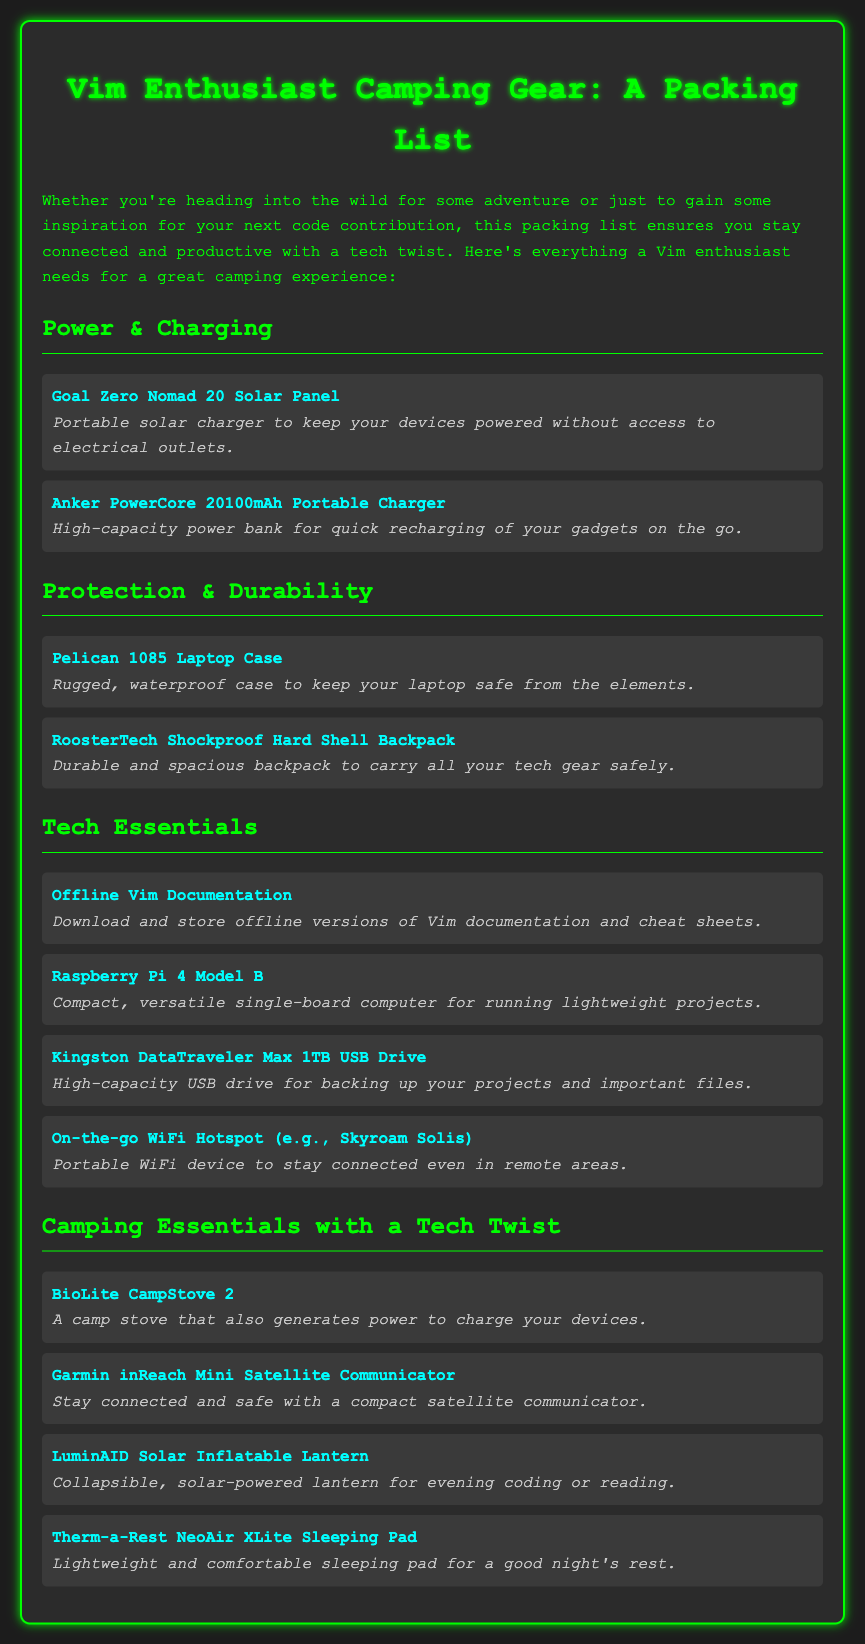what is the name of the portable solar charger? The document lists the "Goal Zero Nomad 20 Solar Panel" as a portable solar charger.
Answer: Goal Zero Nomad 20 Solar Panel how many items are listed under Tech Essentials? The document details four items in the Tech Essentials category.
Answer: 4 what type of device is the Garmin inReach Mini? The Garmin inReach Mini is categorized as a "Satellite Communicator."
Answer: Satellite Communicator what is the purpose of the BioLite CampStove 2? The BioLite CampStove 2 serves as both a camp stove and a power generator for charging devices.
Answer: Generates power what is the storage capacity of Kingston DataTraveler Max USB Drive? The Kingston DataTraveler Max USB Drive has a capacity of 1TB.
Answer: 1TB what kind of protection does the Pelican 1085 case offer? The Pelican 1085 Laptop Case is described as rugged and waterproof, ensuring protection from the elements.
Answer: Rugged, waterproof which item provides a solar-powered light source? The LuminAID Solar Inflatable Lantern is the item that provides solar-powered light.
Answer: LuminAID Solar Inflatable Lantern what is recommended for offline Vim documentation? The document advises to download and store offline versions of Vim documentation and cheat sheets.
Answer: Offline versions of Vim documentation how does the BioLite CampStove 2 charge devices? The BioLite CampStove 2 charges devices while functioning as a camp stove.
Answer: While it cooks 